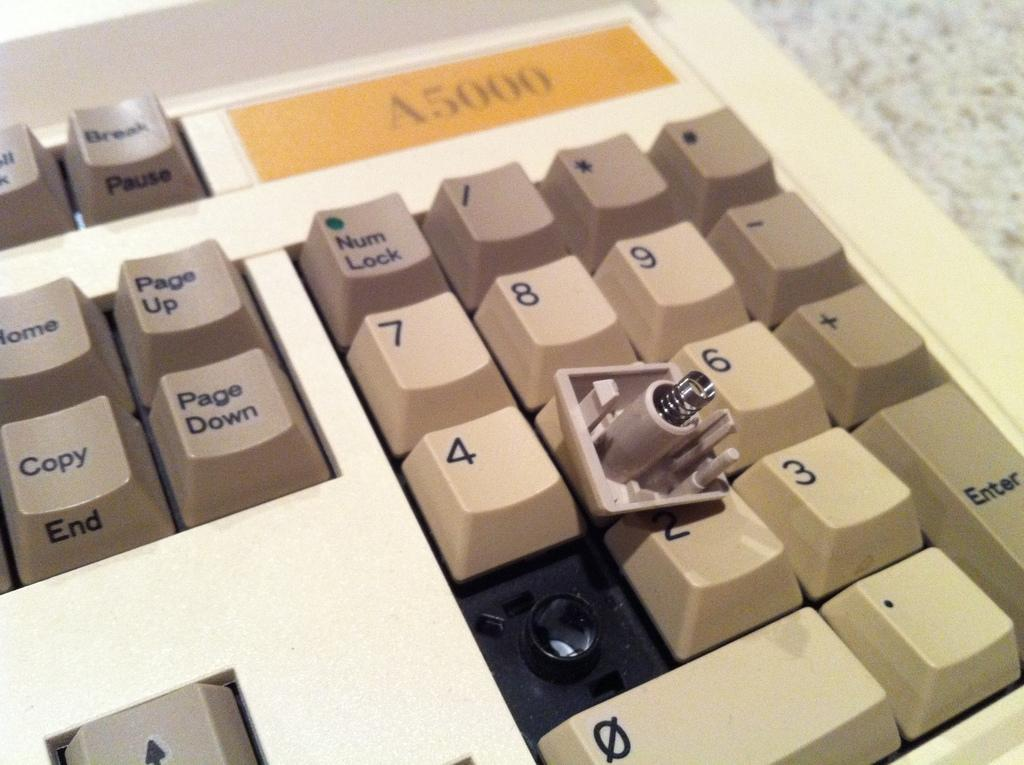<image>
Give a short and clear explanation of the subsequent image. One of the keys on an A5000 keyboard is pulled out of the bracket 